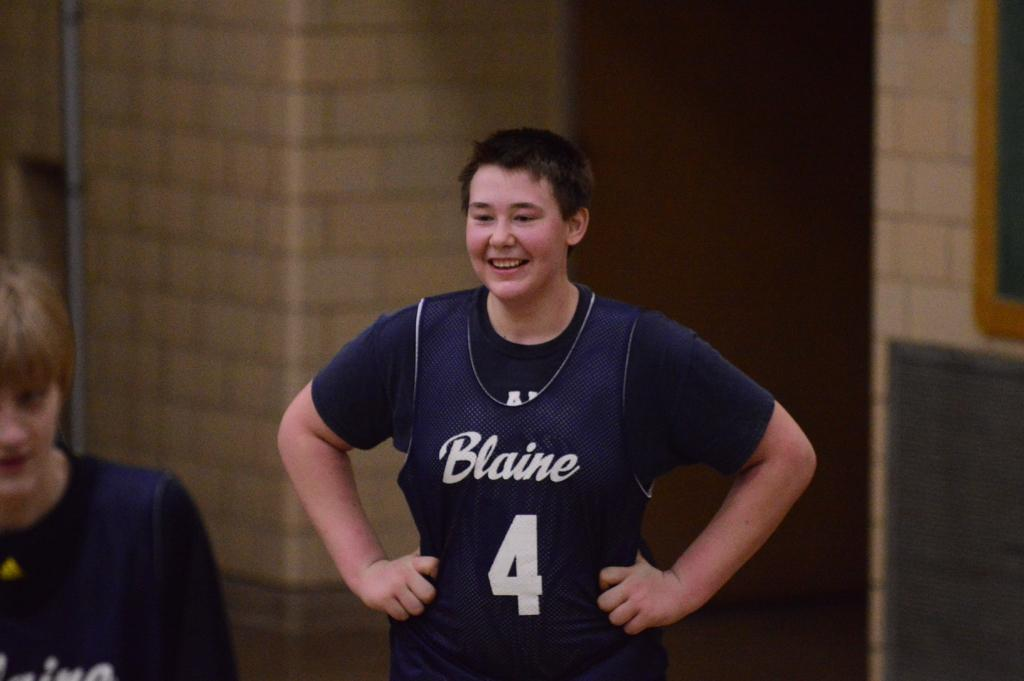Provide a one-sentence caption for the provided image. Blaine sports player number 4 grins at his fellow players. 